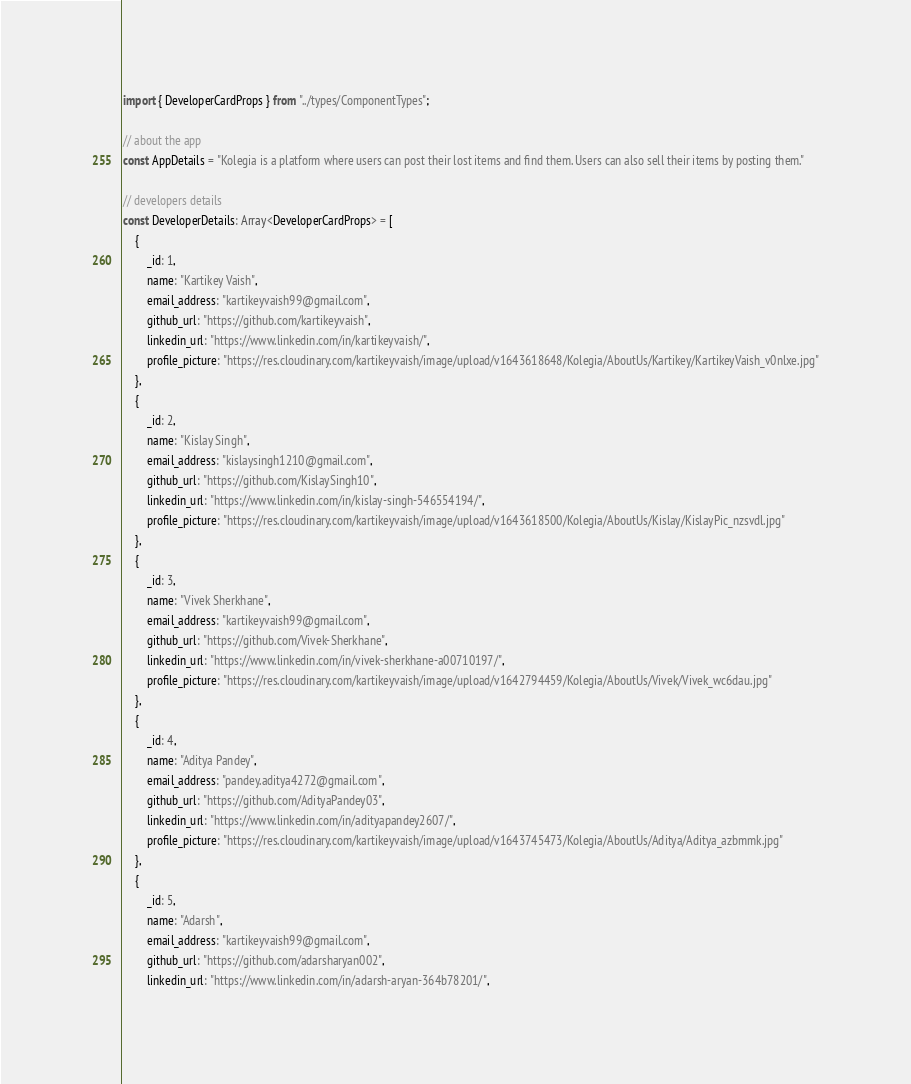Convert code to text. <code><loc_0><loc_0><loc_500><loc_500><_TypeScript_>import { DeveloperCardProps } from "../types/ComponentTypes";

// about the app
const AppDetails = "Kolegia is a platform where users can post their lost items and find them. Users can also sell their items by posting them."

// developers details
const DeveloperDetails: Array<DeveloperCardProps> = [
    {
        _id: 1,
        name: "Kartikey Vaish",
        email_address: "kartikeyvaish99@gmail.com",
        github_url: "https://github.com/kartikeyvaish",
        linkedin_url: "https://www.linkedin.com/in/kartikeyvaish/",
        profile_picture: "https://res.cloudinary.com/kartikeyvaish/image/upload/v1643618648/Kolegia/AboutUs/Kartikey/KartikeyVaish_v0nlxe.jpg"
    },
    {
        _id: 2,
        name: "Kislay Singh",
        email_address: "kislaysingh1210@gmail.com",
        github_url: "https://github.com/KislaySingh10",
        linkedin_url: "https://www.linkedin.com/in/kislay-singh-546554194/",
        profile_picture: "https://res.cloudinary.com/kartikeyvaish/image/upload/v1643618500/Kolegia/AboutUs/Kislay/KislayPic_nzsvdl.jpg"
    },
    {
        _id: 3,
        name: "Vivek Sherkhane",
        email_address: "kartikeyvaish99@gmail.com",
        github_url: "https://github.com/Vivek-Sherkhane",
        linkedin_url: "https://www.linkedin.com/in/vivek-sherkhane-a00710197/",
        profile_picture: "https://res.cloudinary.com/kartikeyvaish/image/upload/v1642794459/Kolegia/AboutUs/Vivek/Vivek_wc6dau.jpg"
    },
    {
        _id: 4,
        name: "Aditya Pandey",
        email_address: "pandey.aditya4272@gmail.com",
        github_url: "https://github.com/AdityaPandey03",
        linkedin_url: "https://www.linkedin.com/in/adityapandey2607/",
        profile_picture: "https://res.cloudinary.com/kartikeyvaish/image/upload/v1643745473/Kolegia/AboutUs/Aditya/Aditya_azbmmk.jpg"
    },
    {
        _id: 5,
        name: "Adarsh",
        email_address: "kartikeyvaish99@gmail.com",
        github_url: "https://github.com/adarsharyan002",
        linkedin_url: "https://www.linkedin.com/in/adarsh-aryan-364b78201/",</code> 